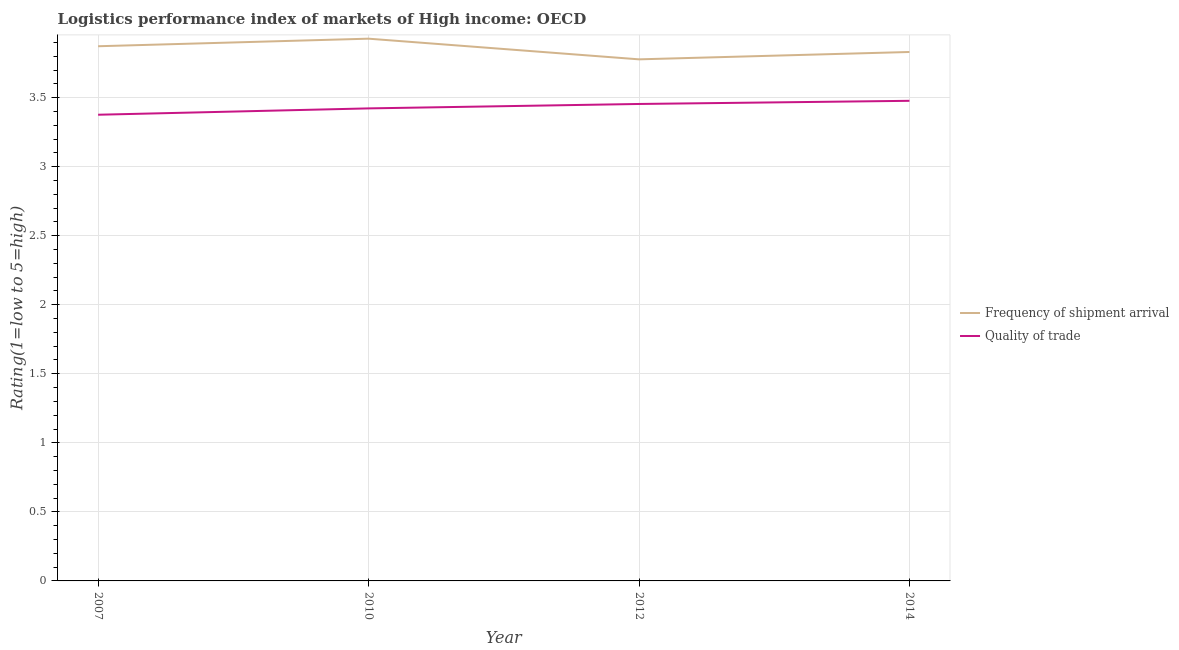What is the lpi quality of trade in 2010?
Provide a succinct answer. 3.42. Across all years, what is the maximum lpi quality of trade?
Keep it short and to the point. 3.48. Across all years, what is the minimum lpi quality of trade?
Offer a terse response. 3.38. What is the total lpi quality of trade in the graph?
Give a very brief answer. 13.73. What is the difference between the lpi quality of trade in 2012 and that in 2014?
Your answer should be compact. -0.02. What is the difference between the lpi of frequency of shipment arrival in 2012 and the lpi quality of trade in 2014?
Your answer should be very brief. 0.3. What is the average lpi of frequency of shipment arrival per year?
Offer a terse response. 3.85. In the year 2007, what is the difference between the lpi of frequency of shipment arrival and lpi quality of trade?
Your answer should be very brief. 0.5. In how many years, is the lpi of frequency of shipment arrival greater than 2.7?
Offer a terse response. 4. What is the ratio of the lpi quality of trade in 2010 to that in 2012?
Provide a short and direct response. 0.99. Is the difference between the lpi of frequency of shipment arrival in 2012 and 2014 greater than the difference between the lpi quality of trade in 2012 and 2014?
Offer a terse response. No. What is the difference between the highest and the second highest lpi of frequency of shipment arrival?
Offer a very short reply. 0.05. What is the difference between the highest and the lowest lpi quality of trade?
Keep it short and to the point. 0.1. Is the sum of the lpi of frequency of shipment arrival in 2010 and 2014 greater than the maximum lpi quality of trade across all years?
Provide a succinct answer. Yes. Does the lpi of frequency of shipment arrival monotonically increase over the years?
Provide a short and direct response. No. Is the lpi of frequency of shipment arrival strictly greater than the lpi quality of trade over the years?
Offer a terse response. Yes. How many lines are there?
Offer a very short reply. 2. Are the values on the major ticks of Y-axis written in scientific E-notation?
Provide a short and direct response. No. Does the graph contain grids?
Provide a succinct answer. Yes. Where does the legend appear in the graph?
Keep it short and to the point. Center right. How are the legend labels stacked?
Your answer should be very brief. Vertical. What is the title of the graph?
Ensure brevity in your answer.  Logistics performance index of markets of High income: OECD. Does "International Tourists" appear as one of the legend labels in the graph?
Provide a short and direct response. No. What is the label or title of the Y-axis?
Your answer should be compact. Rating(1=low to 5=high). What is the Rating(1=low to 5=high) of Frequency of shipment arrival in 2007?
Ensure brevity in your answer.  3.87. What is the Rating(1=low to 5=high) of Quality of trade in 2007?
Offer a terse response. 3.38. What is the Rating(1=low to 5=high) in Frequency of shipment arrival in 2010?
Ensure brevity in your answer.  3.93. What is the Rating(1=low to 5=high) of Quality of trade in 2010?
Offer a terse response. 3.42. What is the Rating(1=low to 5=high) in Frequency of shipment arrival in 2012?
Your answer should be very brief. 3.78. What is the Rating(1=low to 5=high) in Quality of trade in 2012?
Ensure brevity in your answer.  3.45. What is the Rating(1=low to 5=high) of Frequency of shipment arrival in 2014?
Your answer should be compact. 3.83. What is the Rating(1=low to 5=high) of Quality of trade in 2014?
Your response must be concise. 3.48. Across all years, what is the maximum Rating(1=low to 5=high) in Frequency of shipment arrival?
Ensure brevity in your answer.  3.93. Across all years, what is the maximum Rating(1=low to 5=high) in Quality of trade?
Offer a terse response. 3.48. Across all years, what is the minimum Rating(1=low to 5=high) of Frequency of shipment arrival?
Offer a very short reply. 3.78. Across all years, what is the minimum Rating(1=low to 5=high) in Quality of trade?
Offer a terse response. 3.38. What is the total Rating(1=low to 5=high) of Frequency of shipment arrival in the graph?
Give a very brief answer. 15.41. What is the total Rating(1=low to 5=high) of Quality of trade in the graph?
Your answer should be very brief. 13.73. What is the difference between the Rating(1=low to 5=high) of Frequency of shipment arrival in 2007 and that in 2010?
Make the answer very short. -0.05. What is the difference between the Rating(1=low to 5=high) in Quality of trade in 2007 and that in 2010?
Provide a succinct answer. -0.05. What is the difference between the Rating(1=low to 5=high) in Frequency of shipment arrival in 2007 and that in 2012?
Give a very brief answer. 0.09. What is the difference between the Rating(1=low to 5=high) in Quality of trade in 2007 and that in 2012?
Make the answer very short. -0.08. What is the difference between the Rating(1=low to 5=high) of Frequency of shipment arrival in 2007 and that in 2014?
Your answer should be very brief. 0.04. What is the difference between the Rating(1=low to 5=high) of Quality of trade in 2007 and that in 2014?
Ensure brevity in your answer.  -0.1. What is the difference between the Rating(1=low to 5=high) of Frequency of shipment arrival in 2010 and that in 2012?
Make the answer very short. 0.15. What is the difference between the Rating(1=low to 5=high) in Quality of trade in 2010 and that in 2012?
Provide a succinct answer. -0.03. What is the difference between the Rating(1=low to 5=high) in Frequency of shipment arrival in 2010 and that in 2014?
Your response must be concise. 0.1. What is the difference between the Rating(1=low to 5=high) in Quality of trade in 2010 and that in 2014?
Your response must be concise. -0.05. What is the difference between the Rating(1=low to 5=high) of Frequency of shipment arrival in 2012 and that in 2014?
Make the answer very short. -0.05. What is the difference between the Rating(1=low to 5=high) of Quality of trade in 2012 and that in 2014?
Make the answer very short. -0.02. What is the difference between the Rating(1=low to 5=high) of Frequency of shipment arrival in 2007 and the Rating(1=low to 5=high) of Quality of trade in 2010?
Offer a terse response. 0.45. What is the difference between the Rating(1=low to 5=high) in Frequency of shipment arrival in 2007 and the Rating(1=low to 5=high) in Quality of trade in 2012?
Provide a succinct answer. 0.42. What is the difference between the Rating(1=low to 5=high) in Frequency of shipment arrival in 2007 and the Rating(1=low to 5=high) in Quality of trade in 2014?
Give a very brief answer. 0.4. What is the difference between the Rating(1=low to 5=high) in Frequency of shipment arrival in 2010 and the Rating(1=low to 5=high) in Quality of trade in 2012?
Offer a very short reply. 0.47. What is the difference between the Rating(1=low to 5=high) in Frequency of shipment arrival in 2010 and the Rating(1=low to 5=high) in Quality of trade in 2014?
Give a very brief answer. 0.45. What is the difference between the Rating(1=low to 5=high) of Frequency of shipment arrival in 2012 and the Rating(1=low to 5=high) of Quality of trade in 2014?
Keep it short and to the point. 0.3. What is the average Rating(1=low to 5=high) in Frequency of shipment arrival per year?
Your answer should be compact. 3.85. What is the average Rating(1=low to 5=high) in Quality of trade per year?
Give a very brief answer. 3.43. In the year 2007, what is the difference between the Rating(1=low to 5=high) of Frequency of shipment arrival and Rating(1=low to 5=high) of Quality of trade?
Keep it short and to the point. 0.5. In the year 2010, what is the difference between the Rating(1=low to 5=high) in Frequency of shipment arrival and Rating(1=low to 5=high) in Quality of trade?
Make the answer very short. 0.5. In the year 2012, what is the difference between the Rating(1=low to 5=high) of Frequency of shipment arrival and Rating(1=low to 5=high) of Quality of trade?
Your response must be concise. 0.32. In the year 2014, what is the difference between the Rating(1=low to 5=high) in Frequency of shipment arrival and Rating(1=low to 5=high) in Quality of trade?
Your answer should be very brief. 0.35. What is the ratio of the Rating(1=low to 5=high) in Frequency of shipment arrival in 2007 to that in 2010?
Make the answer very short. 0.99. What is the ratio of the Rating(1=low to 5=high) in Quality of trade in 2007 to that in 2010?
Your answer should be very brief. 0.99. What is the ratio of the Rating(1=low to 5=high) of Frequency of shipment arrival in 2007 to that in 2012?
Make the answer very short. 1.03. What is the ratio of the Rating(1=low to 5=high) of Quality of trade in 2007 to that in 2012?
Make the answer very short. 0.98. What is the ratio of the Rating(1=low to 5=high) of Frequency of shipment arrival in 2007 to that in 2014?
Your answer should be compact. 1.01. What is the ratio of the Rating(1=low to 5=high) in Quality of trade in 2007 to that in 2014?
Keep it short and to the point. 0.97. What is the ratio of the Rating(1=low to 5=high) in Frequency of shipment arrival in 2010 to that in 2012?
Your answer should be very brief. 1.04. What is the ratio of the Rating(1=low to 5=high) in Frequency of shipment arrival in 2010 to that in 2014?
Offer a terse response. 1.03. What is the ratio of the Rating(1=low to 5=high) in Quality of trade in 2010 to that in 2014?
Keep it short and to the point. 0.98. What is the ratio of the Rating(1=low to 5=high) in Frequency of shipment arrival in 2012 to that in 2014?
Ensure brevity in your answer.  0.99. What is the ratio of the Rating(1=low to 5=high) in Quality of trade in 2012 to that in 2014?
Give a very brief answer. 0.99. What is the difference between the highest and the second highest Rating(1=low to 5=high) of Frequency of shipment arrival?
Give a very brief answer. 0.05. What is the difference between the highest and the second highest Rating(1=low to 5=high) of Quality of trade?
Provide a succinct answer. 0.02. What is the difference between the highest and the lowest Rating(1=low to 5=high) in Frequency of shipment arrival?
Offer a very short reply. 0.15. What is the difference between the highest and the lowest Rating(1=low to 5=high) of Quality of trade?
Your answer should be compact. 0.1. 